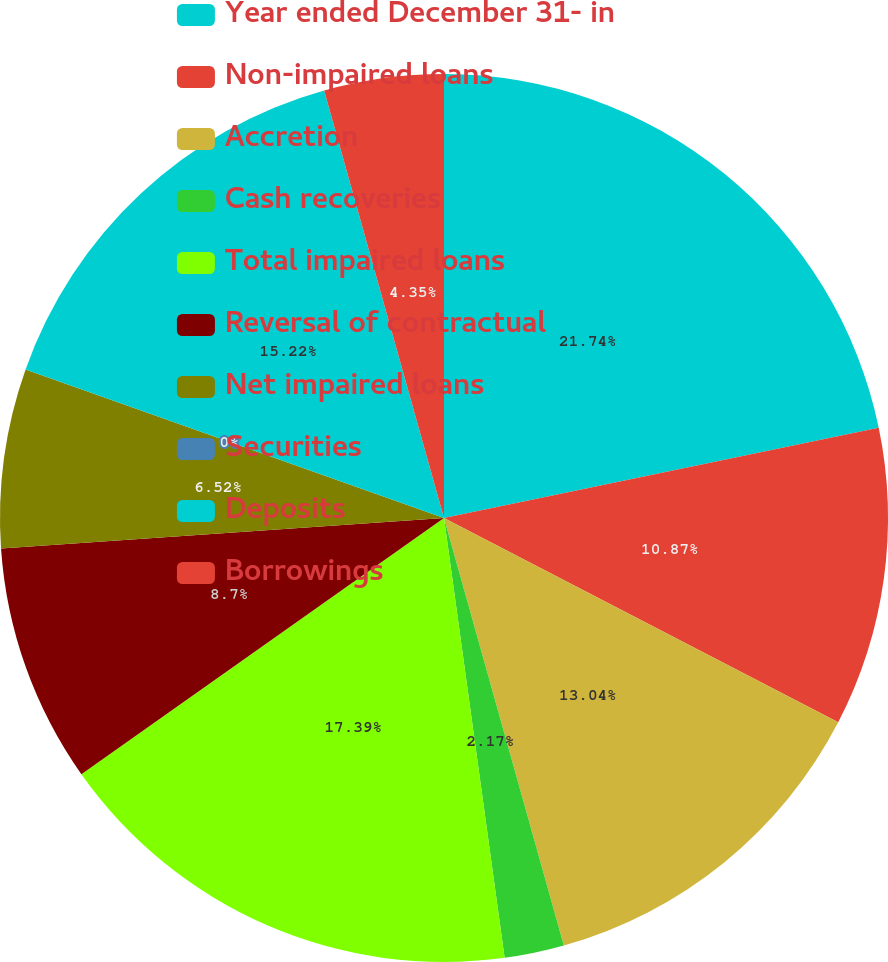<chart> <loc_0><loc_0><loc_500><loc_500><pie_chart><fcel>Year ended December 31- in<fcel>Non-impaired loans<fcel>Accretion<fcel>Cash recoveries<fcel>Total impaired loans<fcel>Reversal of contractual<fcel>Net impaired loans<fcel>Securities<fcel>Deposits<fcel>Borrowings<nl><fcel>21.74%<fcel>10.87%<fcel>13.04%<fcel>2.17%<fcel>17.39%<fcel>8.7%<fcel>6.52%<fcel>0.0%<fcel>15.22%<fcel>4.35%<nl></chart> 